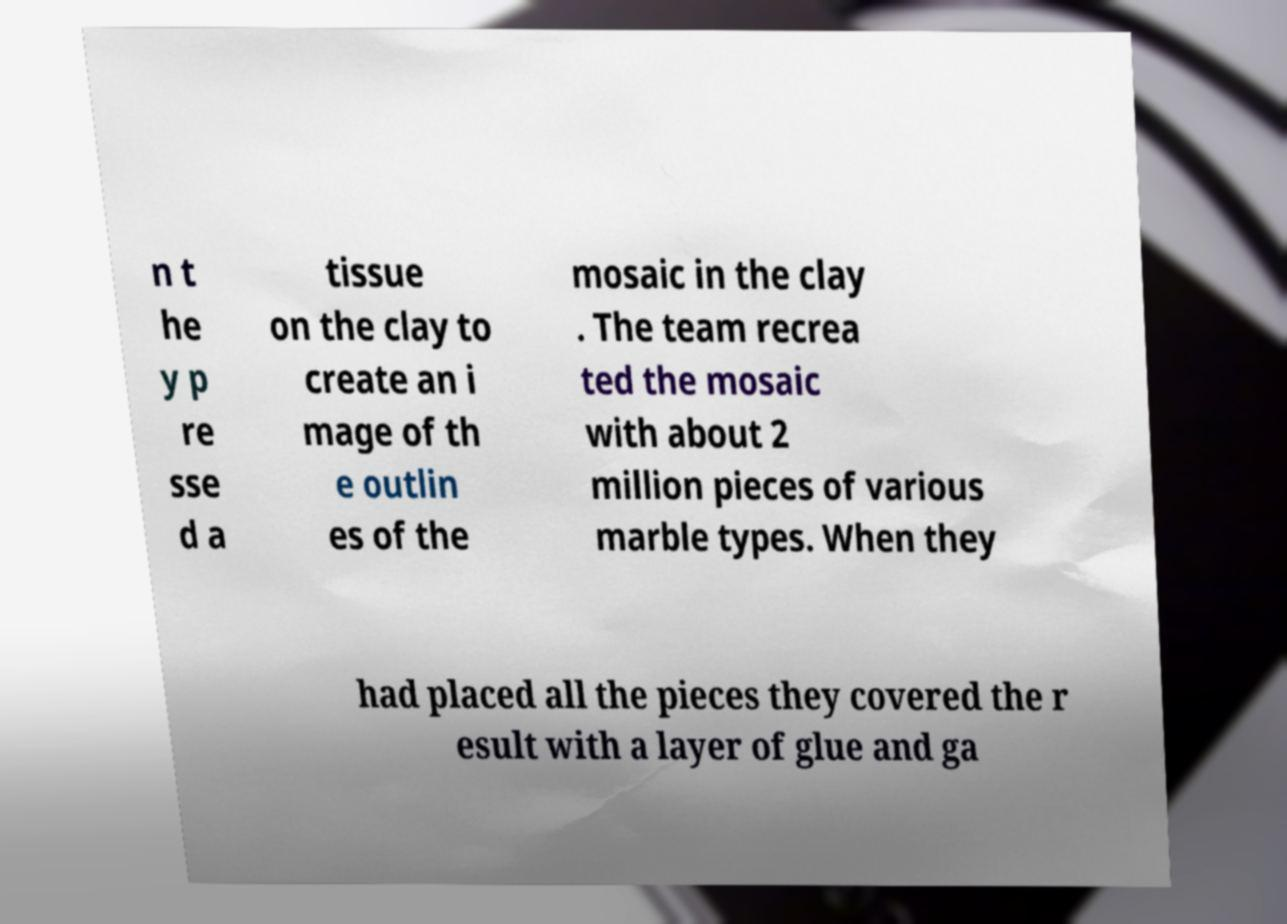Could you assist in decoding the text presented in this image and type it out clearly? n t he y p re sse d a tissue on the clay to create an i mage of th e outlin es of the mosaic in the clay . The team recrea ted the mosaic with about 2 million pieces of various marble types. When they had placed all the pieces they covered the r esult with a layer of glue and ga 